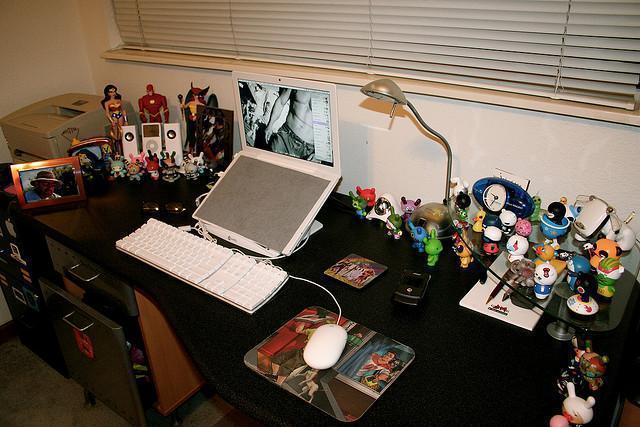Which female superhero is on the left corner of the desk?
Answer the question by selecting the correct answer among the 4 following choices.
Options: Black widow, she hulk, wonder woman, harley quinn. Wonder woman. 